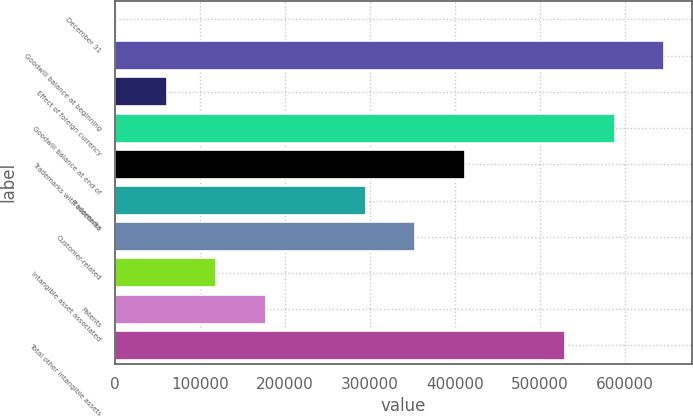Convert chart. <chart><loc_0><loc_0><loc_500><loc_500><bar_chart><fcel>December 31<fcel>Goodwill balance at beginning<fcel>Effect of foreign currency<fcel>Goodwill balance at end of<fcel>Trademarks with indefinite<fcel>Trademarks<fcel>Customer-related<fcel>Intangible asset associated<fcel>Patents<fcel>Total other intangible assets<nl><fcel>2013<fcel>646602<fcel>60612<fcel>588003<fcel>412206<fcel>295008<fcel>353607<fcel>119211<fcel>177810<fcel>529404<nl></chart> 